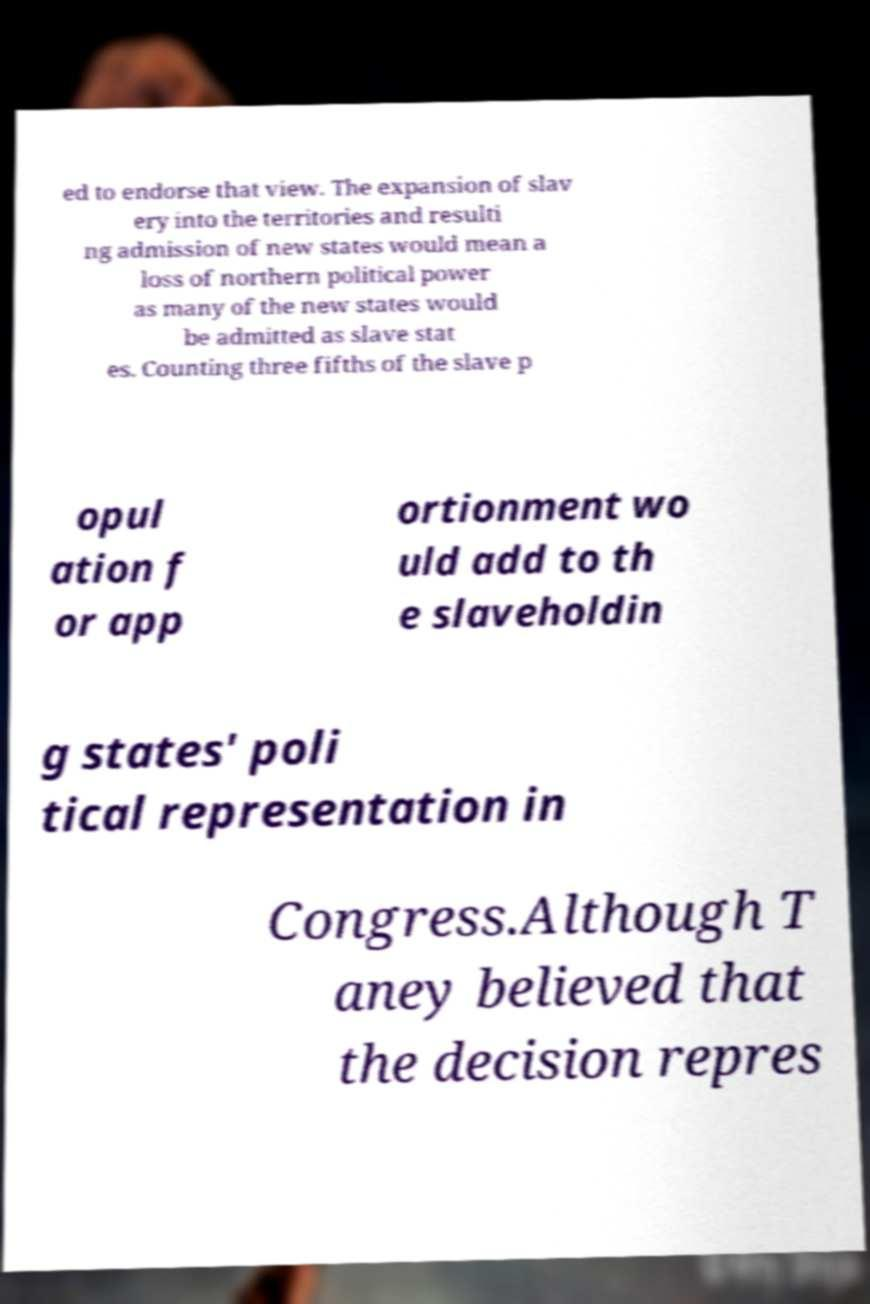Can you accurately transcribe the text from the provided image for me? ed to endorse that view. The expansion of slav ery into the territories and resulti ng admission of new states would mean a loss of northern political power as many of the new states would be admitted as slave stat es. Counting three fifths of the slave p opul ation f or app ortionment wo uld add to th e slaveholdin g states' poli tical representation in Congress.Although T aney believed that the decision repres 